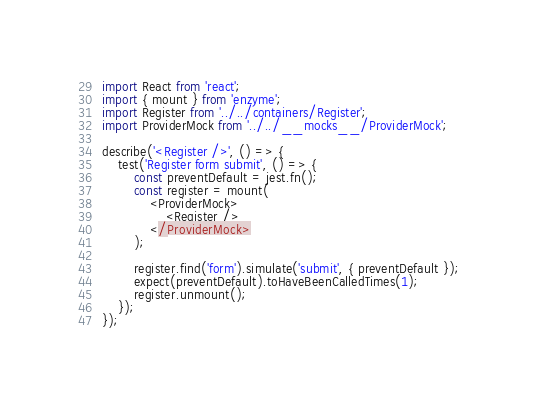Convert code to text. <code><loc_0><loc_0><loc_500><loc_500><_JavaScript_>import React from 'react';
import { mount } from 'enzyme';
import Register from '../../containers/Register';
import ProviderMock from '../../__mocks__/ProviderMock';

describe('<Register />', () => {
    test('Register form submit', () => {
        const preventDefault = jest.fn();
        const register = mount(
            <ProviderMock>
                <Register />
            </ProviderMock>
        );

        register.find('form').simulate('submit', { preventDefault });
        expect(preventDefault).toHaveBeenCalledTimes(1);
        register.unmount();
    });
});
</code> 